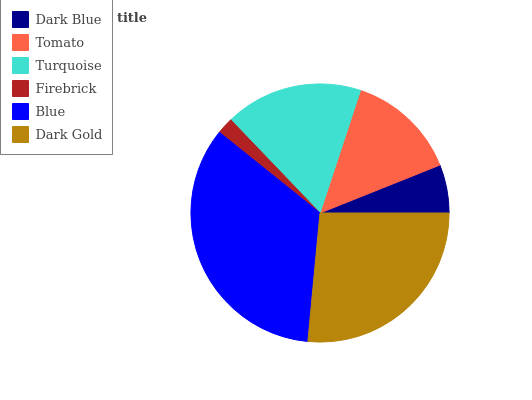Is Firebrick the minimum?
Answer yes or no. Yes. Is Blue the maximum?
Answer yes or no. Yes. Is Tomato the minimum?
Answer yes or no. No. Is Tomato the maximum?
Answer yes or no. No. Is Tomato greater than Dark Blue?
Answer yes or no. Yes. Is Dark Blue less than Tomato?
Answer yes or no. Yes. Is Dark Blue greater than Tomato?
Answer yes or no. No. Is Tomato less than Dark Blue?
Answer yes or no. No. Is Turquoise the high median?
Answer yes or no. Yes. Is Tomato the low median?
Answer yes or no. Yes. Is Tomato the high median?
Answer yes or no. No. Is Turquoise the low median?
Answer yes or no. No. 